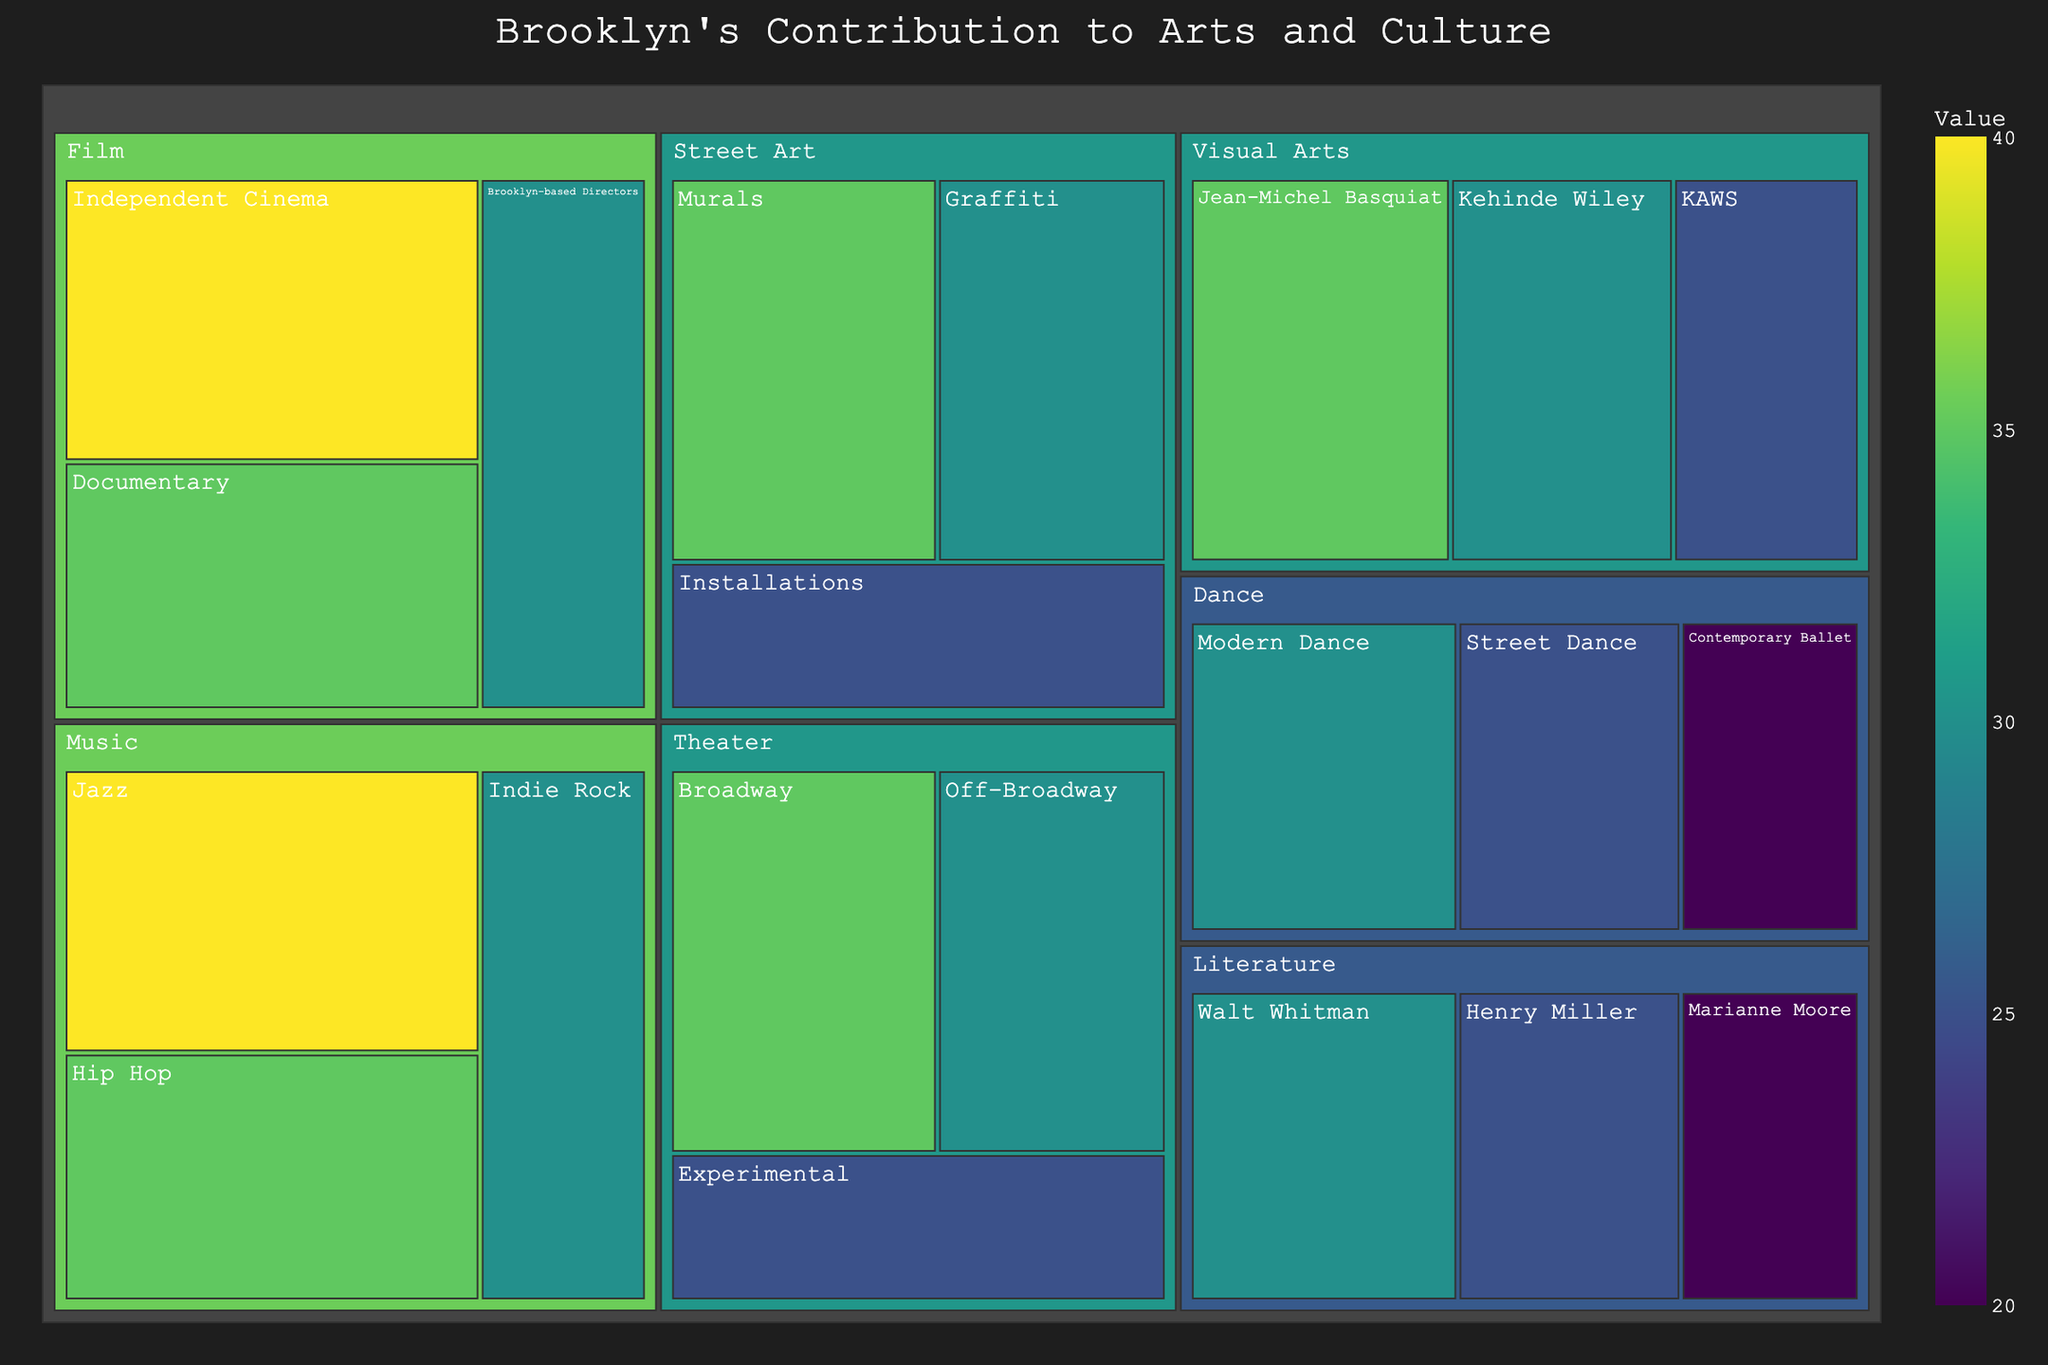How many artistic disciplines are represented in the treemap? Identify and count the unique categories listed in the treemap (Literature, Visual Arts, Music, Theater, Film, Dance, Street Art). There are 7 total.
Answer: 7 Which category has the highest total value? Sum the values of each subcategory within a category, then compare the totals. Music: 40 + 35 + 30 = 105; Film: 40 + 35 + 30 = 105; Both Music and Film have the highest total value.
Answer: Music and Film What's the most prominent subcategory within Visual Arts? Compare the values of subcategories within Visual Arts. Jean-Michel Basquiat: 35, Kehinde Wiley: 30, KAWS: 25. Jean-Michel Basquiat has the highest value.
Answer: Jean-Michel Basquiat What is the combined value for all Literature subcategories? Add the values of all Literature subcategories: Walt Whitman: 30, Henry Miller: 25, Marianne Moore: 20. The sum is 30 + 25 + 20 = 75.
Answer: 75 Which category has the lowest value for its top subcategory? Identify the top subcategory by value in each category, then find the lowest among them. Literature (Walt Whitman): 30, Visual Arts (Jean-Michel Basquiat): 35, Music (Jazz): 40, Theater (Broadway): 35, Film (Independent Cinema): 40, Dance (Modern Dance): 30, Street Art (Murals): 35. Literature and Dance's top subcategory has the lowest value of 30.
Answer: Literature and Dance Which has more value, Theater's Off-Broadway or Dance's Modern Dance? Compare the values: Off-Broadway: 30, Modern Dance: 30. Both have equal value.
Answer: Equal What's the difference in value between Hip Hop and Indie Rock subcategories in Music? Subtract the value of Indie Rock from Hip Hop: Hip Hop: 35, Indie Rock: 30. Difference: 35 - 30 = 5.
Answer: 5 Which subcategory in Film is not the highest but also has a value higher than any subcategory in Literature? Identify Film's subcategories and their values: Independent Cinema: 40, Documentary: 35, Brooklyn-based Directors: 30. Compare with Literature's highest: 30. Documentary: 35 (higher than 30, but not the highest in Film).
Answer: Documentary Which subcategory has the least value in Dance? Compare the values within Dance's subcategories: Modern Dance: 30, Street Dance: 25, Contemporary Ballet: 20. Contemporary Ballet has the least value.
Answer: Contemporary Ballet How does the value of the largest subcategory in Street Art compare to the largest subcategory in Theater? Compare top subcategory values: Street Art (Murals): 35, Theater (Broadway): 35. Both have the same value.
Answer: Equal 